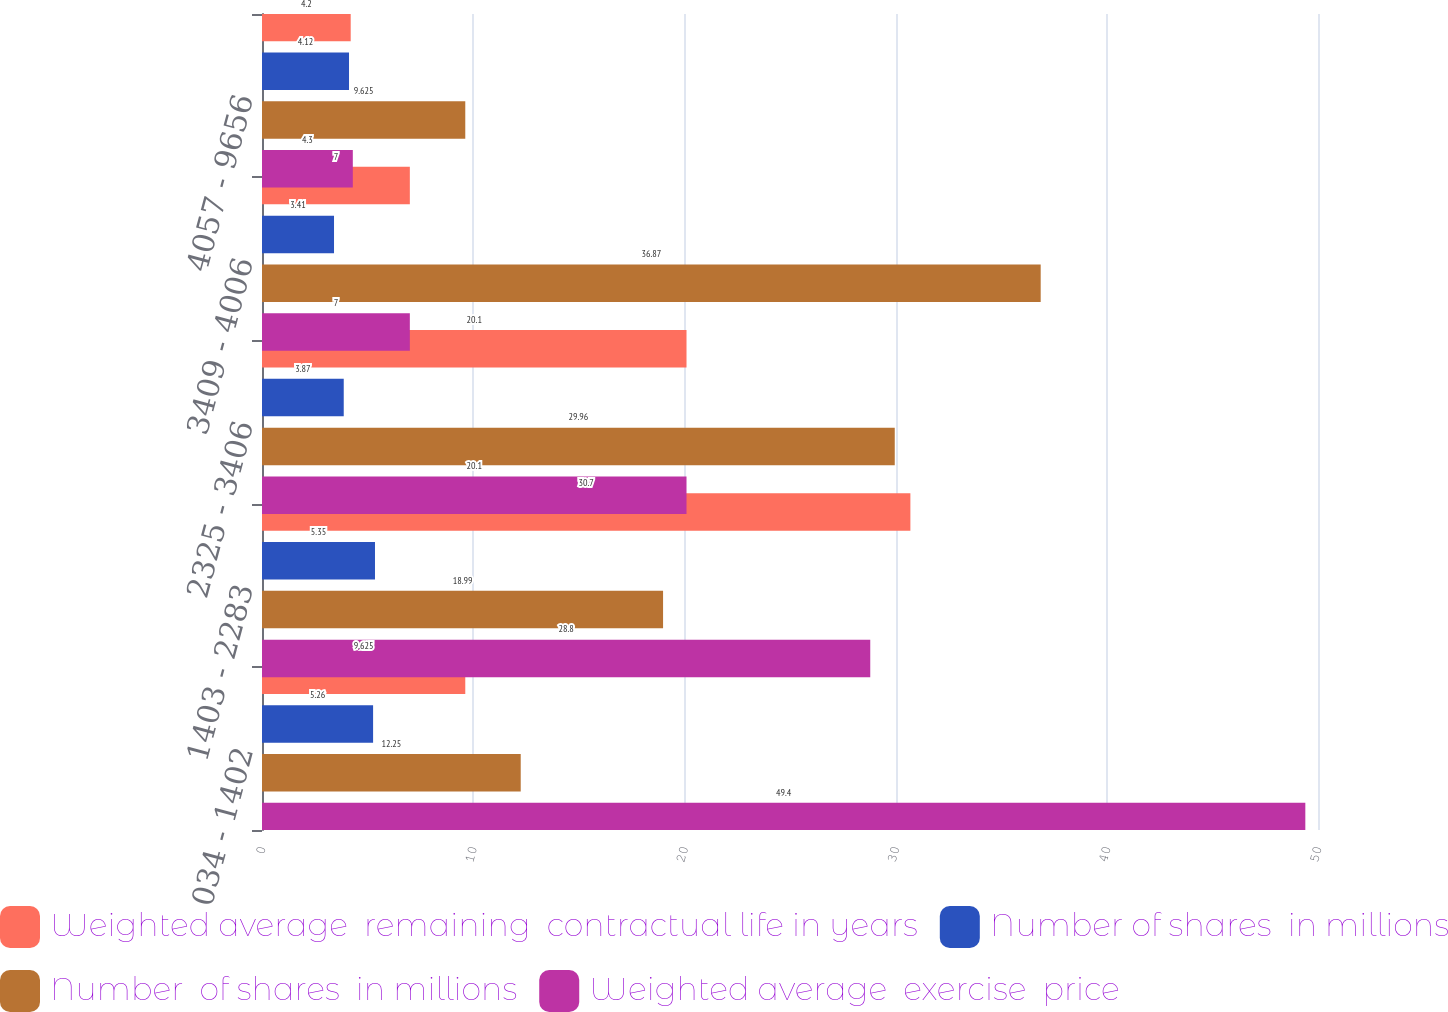Convert chart to OTSL. <chart><loc_0><loc_0><loc_500><loc_500><stacked_bar_chart><ecel><fcel>034 - 1402<fcel>1403 - 2283<fcel>2325 - 3406<fcel>3409 - 4006<fcel>4057 - 9656<nl><fcel>Weighted average  remaining  contractual life in years<fcel>9.625<fcel>30.7<fcel>20.1<fcel>7<fcel>4.2<nl><fcel>Number of shares  in millions<fcel>5.26<fcel>5.35<fcel>3.87<fcel>3.41<fcel>4.12<nl><fcel>Number  of shares  in millions<fcel>12.25<fcel>18.99<fcel>29.96<fcel>36.87<fcel>9.625<nl><fcel>Weighted average  exercise  price<fcel>49.4<fcel>28.8<fcel>20.1<fcel>7<fcel>4.3<nl></chart> 